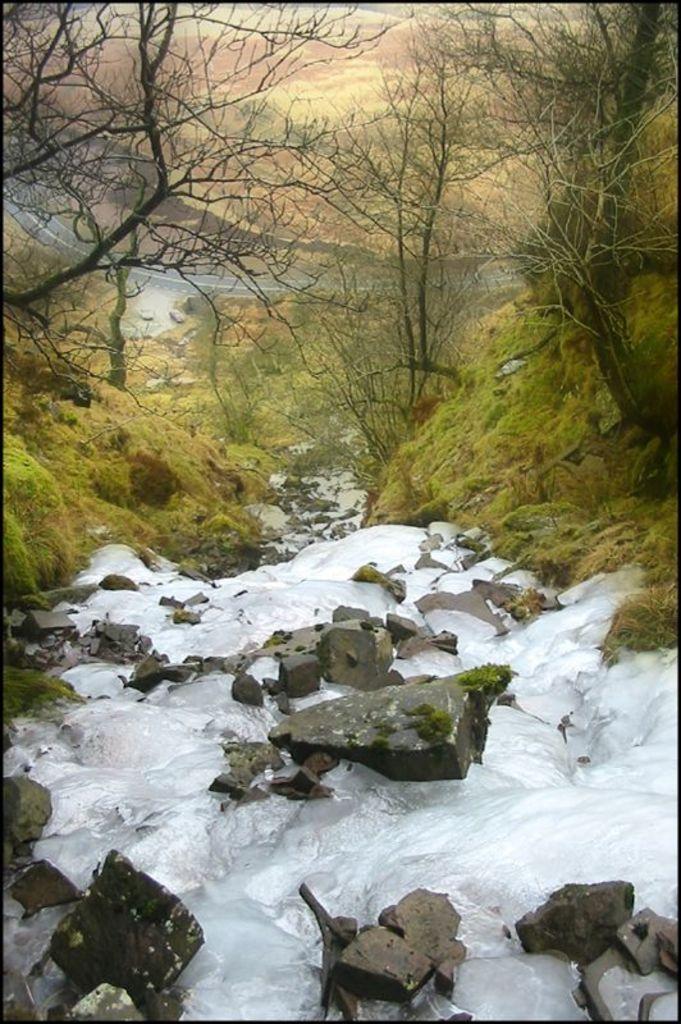Could you give a brief overview of what you see in this image? In this picture we can see water, some stones, grass and in the background we can see trees. 